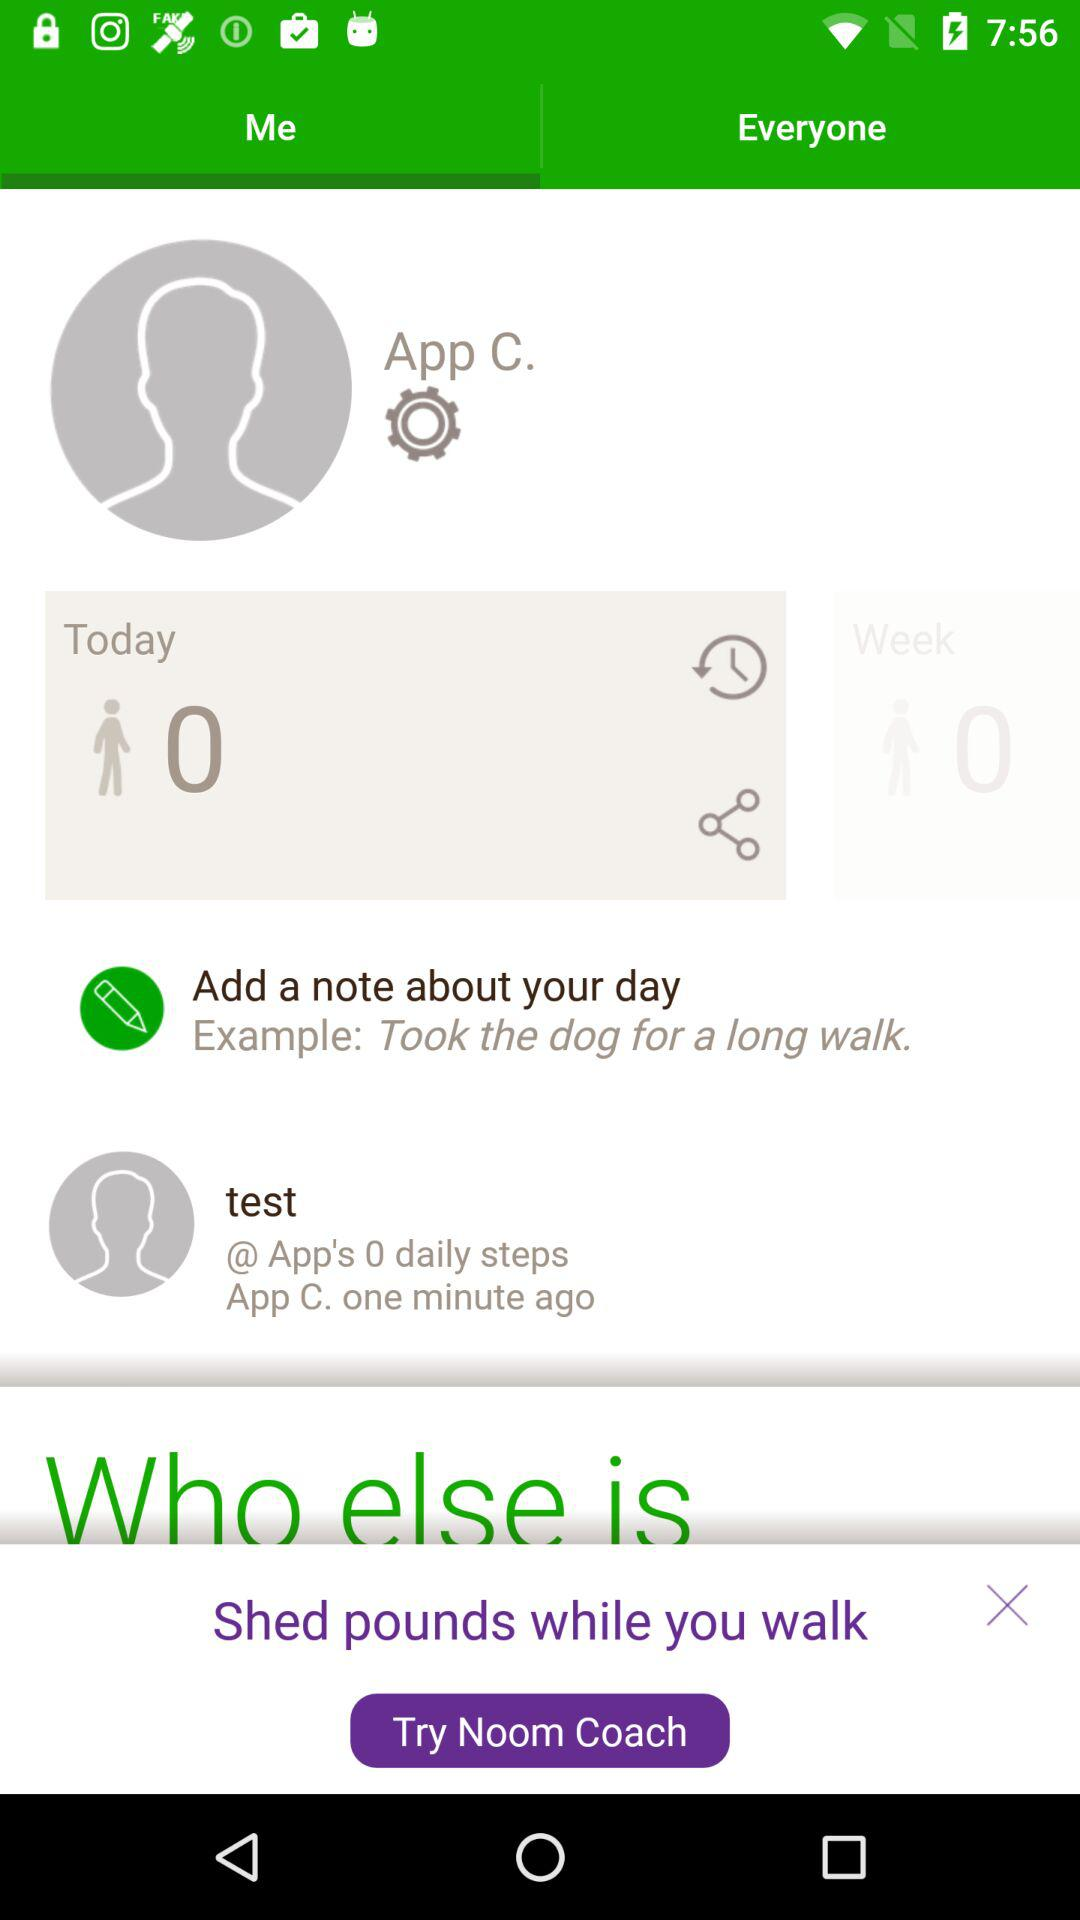What is the name of the user? The name of the user is App C. 